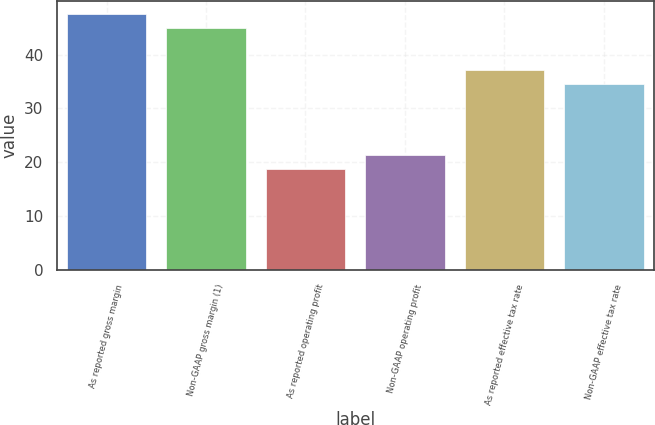Convert chart to OTSL. <chart><loc_0><loc_0><loc_500><loc_500><bar_chart><fcel>As reported gross margin<fcel>Non-GAAP gross margin (1)<fcel>As reported operating profit<fcel>Non-GAAP operating profit<fcel>As reported effective tax rate<fcel>Non-GAAP effective tax rate<nl><fcel>47.52<fcel>44.9<fcel>18.8<fcel>21.42<fcel>37.12<fcel>34.5<nl></chart> 